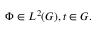Convert formula to latex. <formula><loc_0><loc_0><loc_500><loc_500>\Phi \in L ^ { 2 } ( G ) , t \in G .</formula> 